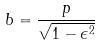<formula> <loc_0><loc_0><loc_500><loc_500>b = \frac { p } { \sqrt { 1 - \epsilon ^ { 2 } } }</formula> 